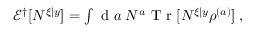<formula> <loc_0><loc_0><loc_500><loc_500>\begin{array} { r } { \mathcal { E } ^ { \dagger } [ N ^ { \xi | y } ] = \int d a \, N ^ { a } T r [ N ^ { \xi | y } \rho ^ { ( a ) } ] \, , } \end{array}</formula> 